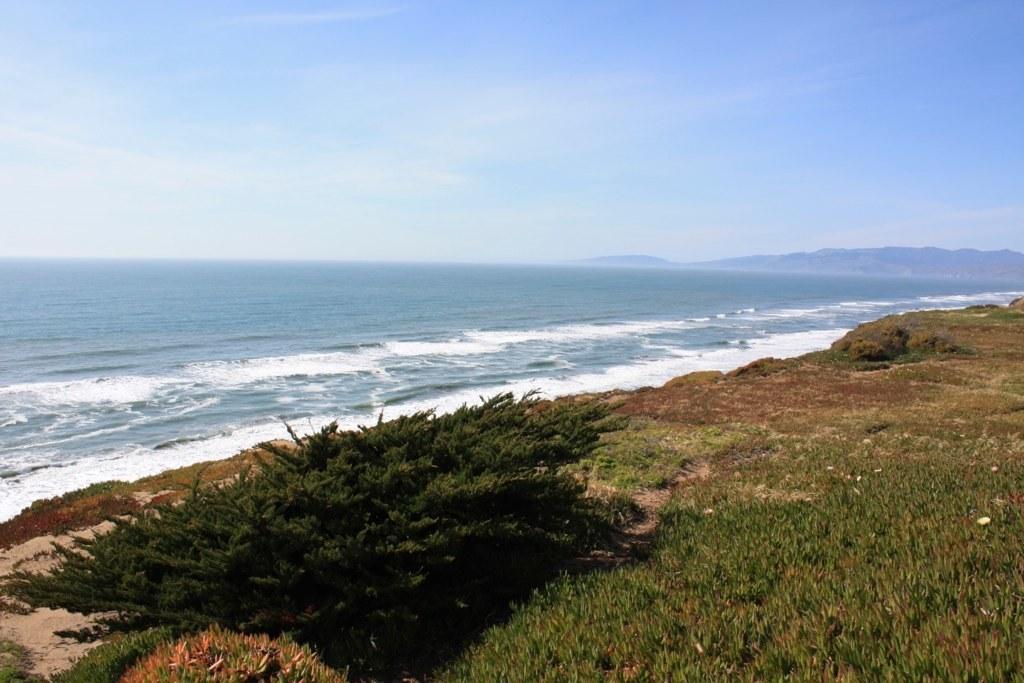Could you give a brief overview of what you see in this image? In this image there is the sky, there are mountains truncated towards the right of the image, there is the sea, there are plants, there is grass, there is plant truncated towards the bottom of the image, there is grass truncated towards the bottom of the image. 